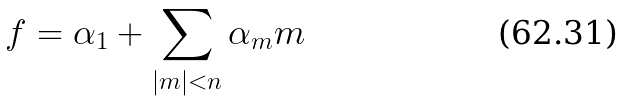Convert formula to latex. <formula><loc_0><loc_0><loc_500><loc_500>f = \alpha _ { 1 } + \sum _ { | m | < n } \alpha _ { m } m</formula> 